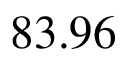Convert formula to latex. <formula><loc_0><loc_0><loc_500><loc_500>8 3 . 9 6 \</formula> 